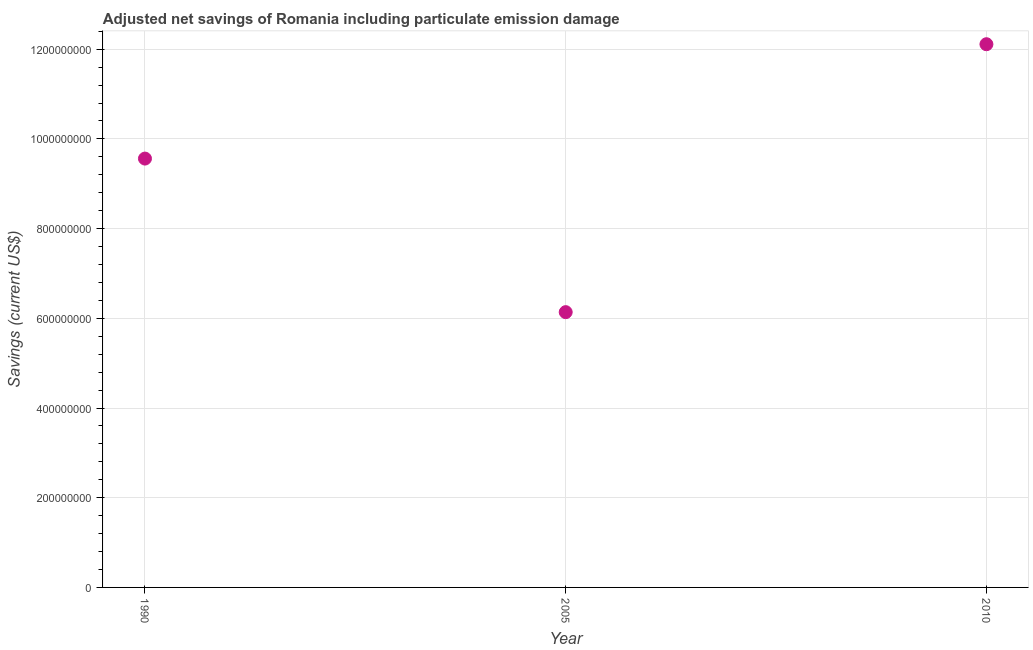What is the adjusted net savings in 1990?
Your answer should be compact. 9.56e+08. Across all years, what is the maximum adjusted net savings?
Provide a succinct answer. 1.21e+09. Across all years, what is the minimum adjusted net savings?
Your answer should be very brief. 6.14e+08. In which year was the adjusted net savings maximum?
Provide a short and direct response. 2010. What is the sum of the adjusted net savings?
Give a very brief answer. 2.78e+09. What is the difference between the adjusted net savings in 2005 and 2010?
Keep it short and to the point. -5.97e+08. What is the average adjusted net savings per year?
Ensure brevity in your answer.  9.27e+08. What is the median adjusted net savings?
Make the answer very short. 9.56e+08. In how many years, is the adjusted net savings greater than 40000000 US$?
Offer a terse response. 3. What is the ratio of the adjusted net savings in 1990 to that in 2010?
Your answer should be compact. 0.79. Is the adjusted net savings in 1990 less than that in 2005?
Offer a terse response. No. Is the difference between the adjusted net savings in 1990 and 2005 greater than the difference between any two years?
Your answer should be very brief. No. What is the difference between the highest and the second highest adjusted net savings?
Offer a terse response. 2.55e+08. Is the sum of the adjusted net savings in 1990 and 2005 greater than the maximum adjusted net savings across all years?
Your response must be concise. Yes. What is the difference between the highest and the lowest adjusted net savings?
Provide a succinct answer. 5.97e+08. In how many years, is the adjusted net savings greater than the average adjusted net savings taken over all years?
Your answer should be compact. 2. How many years are there in the graph?
Provide a short and direct response. 3. Does the graph contain any zero values?
Ensure brevity in your answer.  No. Does the graph contain grids?
Your answer should be compact. Yes. What is the title of the graph?
Your response must be concise. Adjusted net savings of Romania including particulate emission damage. What is the label or title of the X-axis?
Ensure brevity in your answer.  Year. What is the label or title of the Y-axis?
Your answer should be compact. Savings (current US$). What is the Savings (current US$) in 1990?
Offer a terse response. 9.56e+08. What is the Savings (current US$) in 2005?
Your answer should be compact. 6.14e+08. What is the Savings (current US$) in 2010?
Your response must be concise. 1.21e+09. What is the difference between the Savings (current US$) in 1990 and 2005?
Keep it short and to the point. 3.42e+08. What is the difference between the Savings (current US$) in 1990 and 2010?
Make the answer very short. -2.55e+08. What is the difference between the Savings (current US$) in 2005 and 2010?
Your answer should be very brief. -5.97e+08. What is the ratio of the Savings (current US$) in 1990 to that in 2005?
Your response must be concise. 1.56. What is the ratio of the Savings (current US$) in 1990 to that in 2010?
Ensure brevity in your answer.  0.79. What is the ratio of the Savings (current US$) in 2005 to that in 2010?
Keep it short and to the point. 0.51. 